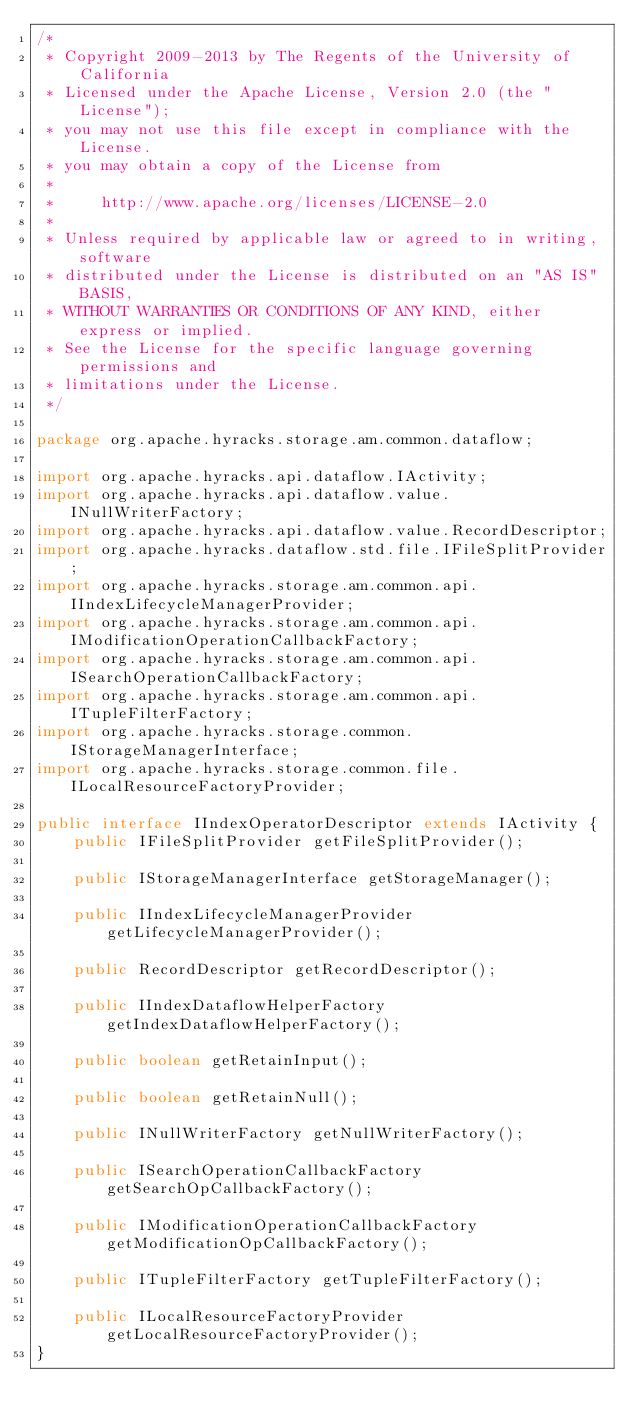<code> <loc_0><loc_0><loc_500><loc_500><_Java_>/*
 * Copyright 2009-2013 by The Regents of the University of California
 * Licensed under the Apache License, Version 2.0 (the "License");
 * you may not use this file except in compliance with the License.
 * you may obtain a copy of the License from
 * 
 *     http://www.apache.org/licenses/LICENSE-2.0
 * 
 * Unless required by applicable law or agreed to in writing, software
 * distributed under the License is distributed on an "AS IS" BASIS,
 * WITHOUT WARRANTIES OR CONDITIONS OF ANY KIND, either express or implied.
 * See the License for the specific language governing permissions and
 * limitations under the License.
 */

package org.apache.hyracks.storage.am.common.dataflow;

import org.apache.hyracks.api.dataflow.IActivity;
import org.apache.hyracks.api.dataflow.value.INullWriterFactory;
import org.apache.hyracks.api.dataflow.value.RecordDescriptor;
import org.apache.hyracks.dataflow.std.file.IFileSplitProvider;
import org.apache.hyracks.storage.am.common.api.IIndexLifecycleManagerProvider;
import org.apache.hyracks.storage.am.common.api.IModificationOperationCallbackFactory;
import org.apache.hyracks.storage.am.common.api.ISearchOperationCallbackFactory;
import org.apache.hyracks.storage.am.common.api.ITupleFilterFactory;
import org.apache.hyracks.storage.common.IStorageManagerInterface;
import org.apache.hyracks.storage.common.file.ILocalResourceFactoryProvider;

public interface IIndexOperatorDescriptor extends IActivity {
    public IFileSplitProvider getFileSplitProvider();

    public IStorageManagerInterface getStorageManager();

    public IIndexLifecycleManagerProvider getLifecycleManagerProvider();

    public RecordDescriptor getRecordDescriptor();

    public IIndexDataflowHelperFactory getIndexDataflowHelperFactory();

    public boolean getRetainInput();

    public boolean getRetainNull();

    public INullWriterFactory getNullWriterFactory();

    public ISearchOperationCallbackFactory getSearchOpCallbackFactory();

    public IModificationOperationCallbackFactory getModificationOpCallbackFactory();

    public ITupleFilterFactory getTupleFilterFactory();

    public ILocalResourceFactoryProvider getLocalResourceFactoryProvider();
}
</code> 